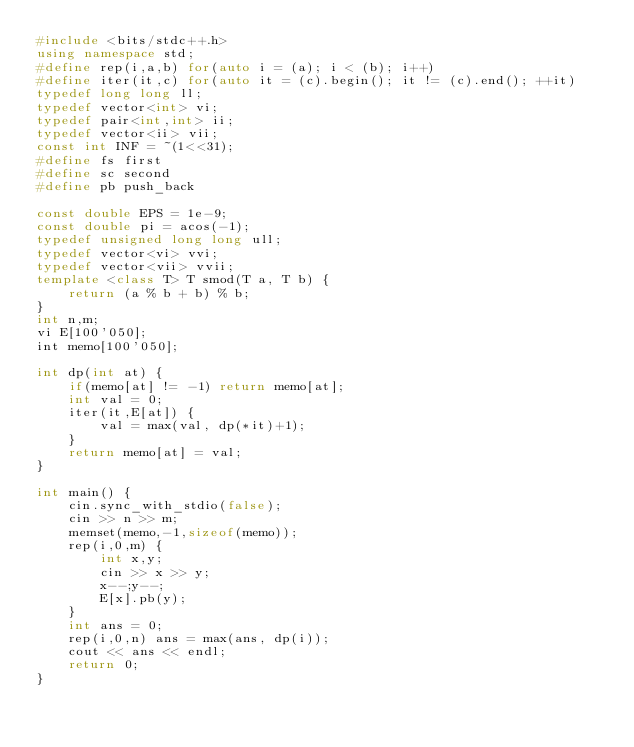Convert code to text. <code><loc_0><loc_0><loc_500><loc_500><_C++_>#include <bits/stdc++.h>
using namespace std;
#define rep(i,a,b) for(auto i = (a); i < (b); i++)
#define iter(it,c) for(auto it = (c).begin(); it != (c).end(); ++it)
typedef long long ll;
typedef vector<int> vi;
typedef pair<int,int> ii;
typedef vector<ii> vii;
const int INF = ~(1<<31);
#define fs first
#define sc second
#define pb push_back

const double EPS = 1e-9;
const double pi = acos(-1);
typedef unsigned long long ull;
typedef vector<vi> vvi;
typedef vector<vii> vvii;
template <class T> T smod(T a, T b) {
    return (a % b + b) % b;
}
int n,m;
vi E[100'050];
int memo[100'050];

int dp(int at) {
    if(memo[at] != -1) return memo[at];
    int val = 0;
    iter(it,E[at]) {
        val = max(val, dp(*it)+1);
    }
    return memo[at] = val;
}

int main() {
    cin.sync_with_stdio(false);
    cin >> n >> m;
    memset(memo,-1,sizeof(memo));
    rep(i,0,m) {
        int x,y;
        cin >> x >> y;
        x--;y--;
        E[x].pb(y);
    }
    int ans = 0;
    rep(i,0,n) ans = max(ans, dp(i));
    cout << ans << endl;
    return 0;
}
</code> 